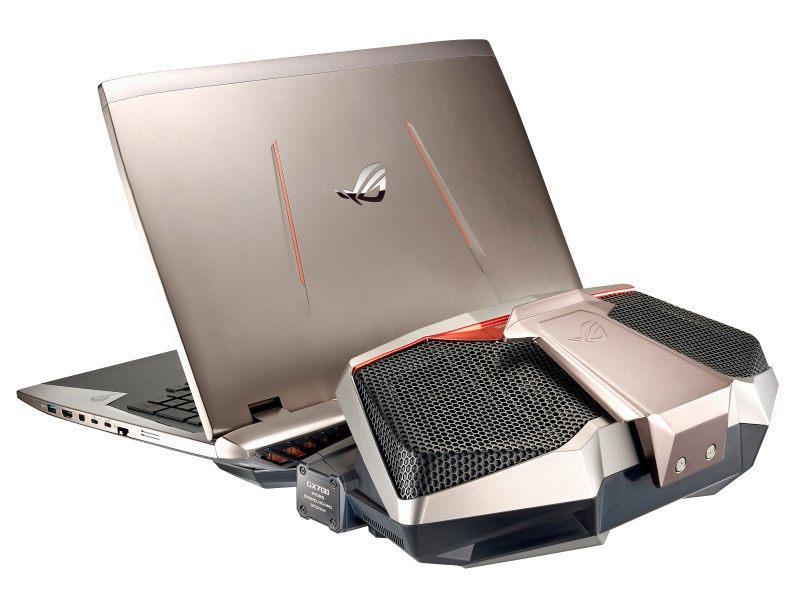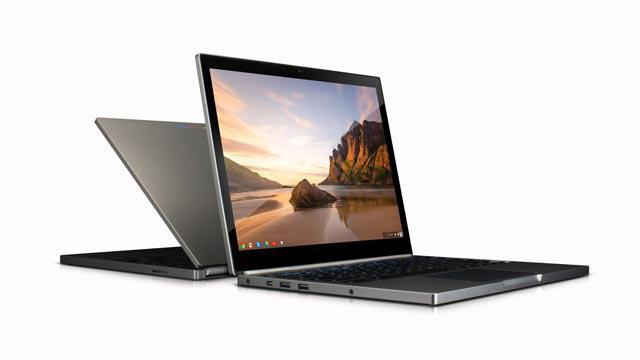The first image is the image on the left, the second image is the image on the right. For the images displayed, is the sentence "In at least one image there is a laptop facing front right with a white box on the screen." factually correct? Answer yes or no. No. The first image is the image on the left, the second image is the image on the right. Considering the images on both sides, is "Each image shows one laptop open to at least 90-degrees and displaying a landscape with sky, and the laptops on the left and right face the same general direction." valid? Answer yes or no. No. 